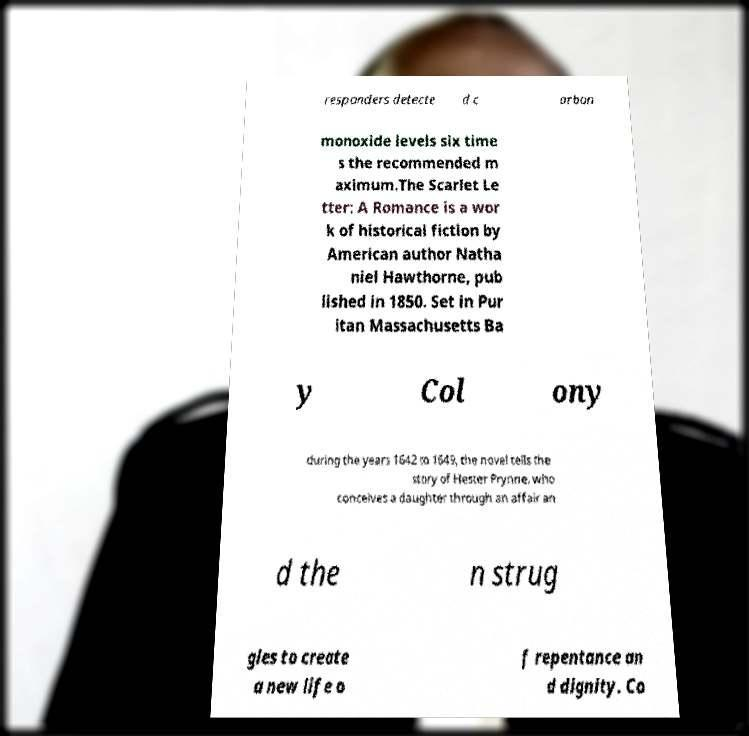Can you read and provide the text displayed in the image?This photo seems to have some interesting text. Can you extract and type it out for me? responders detecte d c arbon monoxide levels six time s the recommended m aximum.The Scarlet Le tter: A Romance is a wor k of historical fiction by American author Natha niel Hawthorne, pub lished in 1850. Set in Pur itan Massachusetts Ba y Col ony during the years 1642 to 1649, the novel tells the story of Hester Prynne, who conceives a daughter through an affair an d the n strug gles to create a new life o f repentance an d dignity. Co 